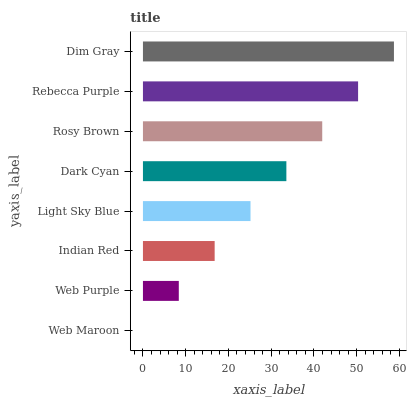Is Web Maroon the minimum?
Answer yes or no. Yes. Is Dim Gray the maximum?
Answer yes or no. Yes. Is Web Purple the minimum?
Answer yes or no. No. Is Web Purple the maximum?
Answer yes or no. No. Is Web Purple greater than Web Maroon?
Answer yes or no. Yes. Is Web Maroon less than Web Purple?
Answer yes or no. Yes. Is Web Maroon greater than Web Purple?
Answer yes or no. No. Is Web Purple less than Web Maroon?
Answer yes or no. No. Is Dark Cyan the high median?
Answer yes or no. Yes. Is Light Sky Blue the low median?
Answer yes or no. Yes. Is Dim Gray the high median?
Answer yes or no. No. Is Rebecca Purple the low median?
Answer yes or no. No. 